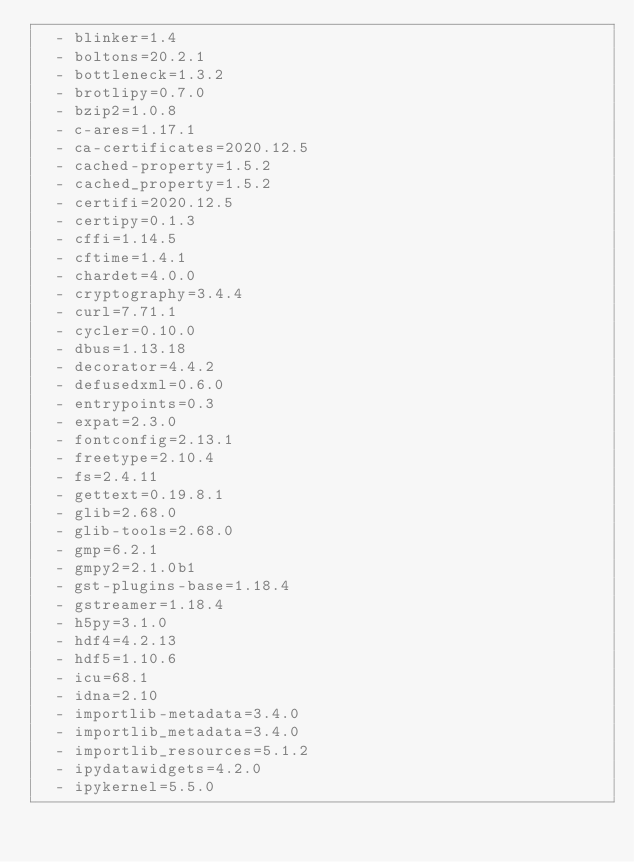<code> <loc_0><loc_0><loc_500><loc_500><_YAML_>  - blinker=1.4
  - boltons=20.2.1
  - bottleneck=1.3.2
  - brotlipy=0.7.0
  - bzip2=1.0.8
  - c-ares=1.17.1
  - ca-certificates=2020.12.5
  - cached-property=1.5.2
  - cached_property=1.5.2
  - certifi=2020.12.5
  - certipy=0.1.3
  - cffi=1.14.5
  - cftime=1.4.1
  - chardet=4.0.0
  - cryptography=3.4.4
  - curl=7.71.1
  - cycler=0.10.0
  - dbus=1.13.18
  - decorator=4.4.2
  - defusedxml=0.6.0
  - entrypoints=0.3
  - expat=2.3.0
  - fontconfig=2.13.1
  - freetype=2.10.4
  - fs=2.4.11
  - gettext=0.19.8.1
  - glib=2.68.0
  - glib-tools=2.68.0
  - gmp=6.2.1
  - gmpy2=2.1.0b1
  - gst-plugins-base=1.18.4
  - gstreamer=1.18.4
  - h5py=3.1.0
  - hdf4=4.2.13
  - hdf5=1.10.6
  - icu=68.1
  - idna=2.10
  - importlib-metadata=3.4.0
  - importlib_metadata=3.4.0
  - importlib_resources=5.1.2
  - ipydatawidgets=4.2.0
  - ipykernel=5.5.0</code> 